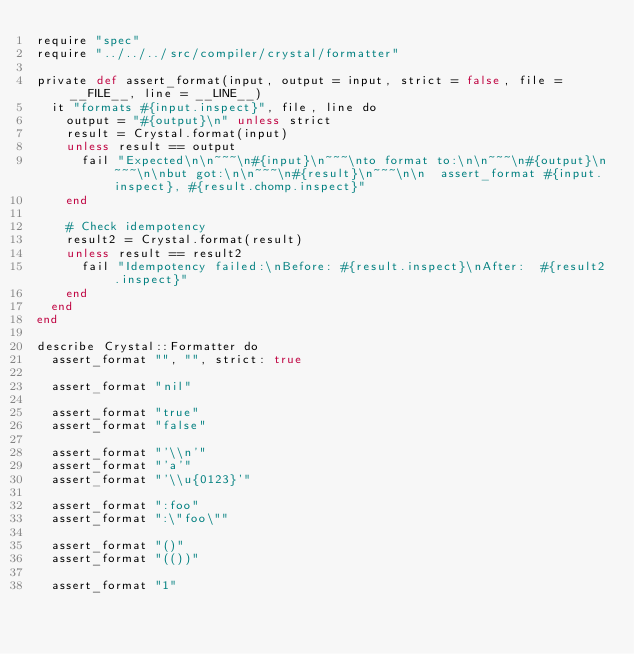Convert code to text. <code><loc_0><loc_0><loc_500><loc_500><_Crystal_>require "spec"
require "../../../src/compiler/crystal/formatter"

private def assert_format(input, output = input, strict = false, file = __FILE__, line = __LINE__)
  it "formats #{input.inspect}", file, line do
    output = "#{output}\n" unless strict
    result = Crystal.format(input)
    unless result == output
      fail "Expected\n\n~~~\n#{input}\n~~~\nto format to:\n\n~~~\n#{output}\n~~~\n\nbut got:\n\n~~~\n#{result}\n~~~\n\n  assert_format #{input.inspect}, #{result.chomp.inspect}"
    end

    # Check idempotency
    result2 = Crystal.format(result)
    unless result == result2
      fail "Idempotency failed:\nBefore: #{result.inspect}\nAfter:  #{result2.inspect}"
    end
  end
end

describe Crystal::Formatter do
  assert_format "", "", strict: true

  assert_format "nil"

  assert_format "true"
  assert_format "false"

  assert_format "'\\n'"
  assert_format "'a'"
  assert_format "'\\u{0123}'"

  assert_format ":foo"
  assert_format ":\"foo\""

  assert_format "()"
  assert_format "(())"

  assert_format "1"</code> 